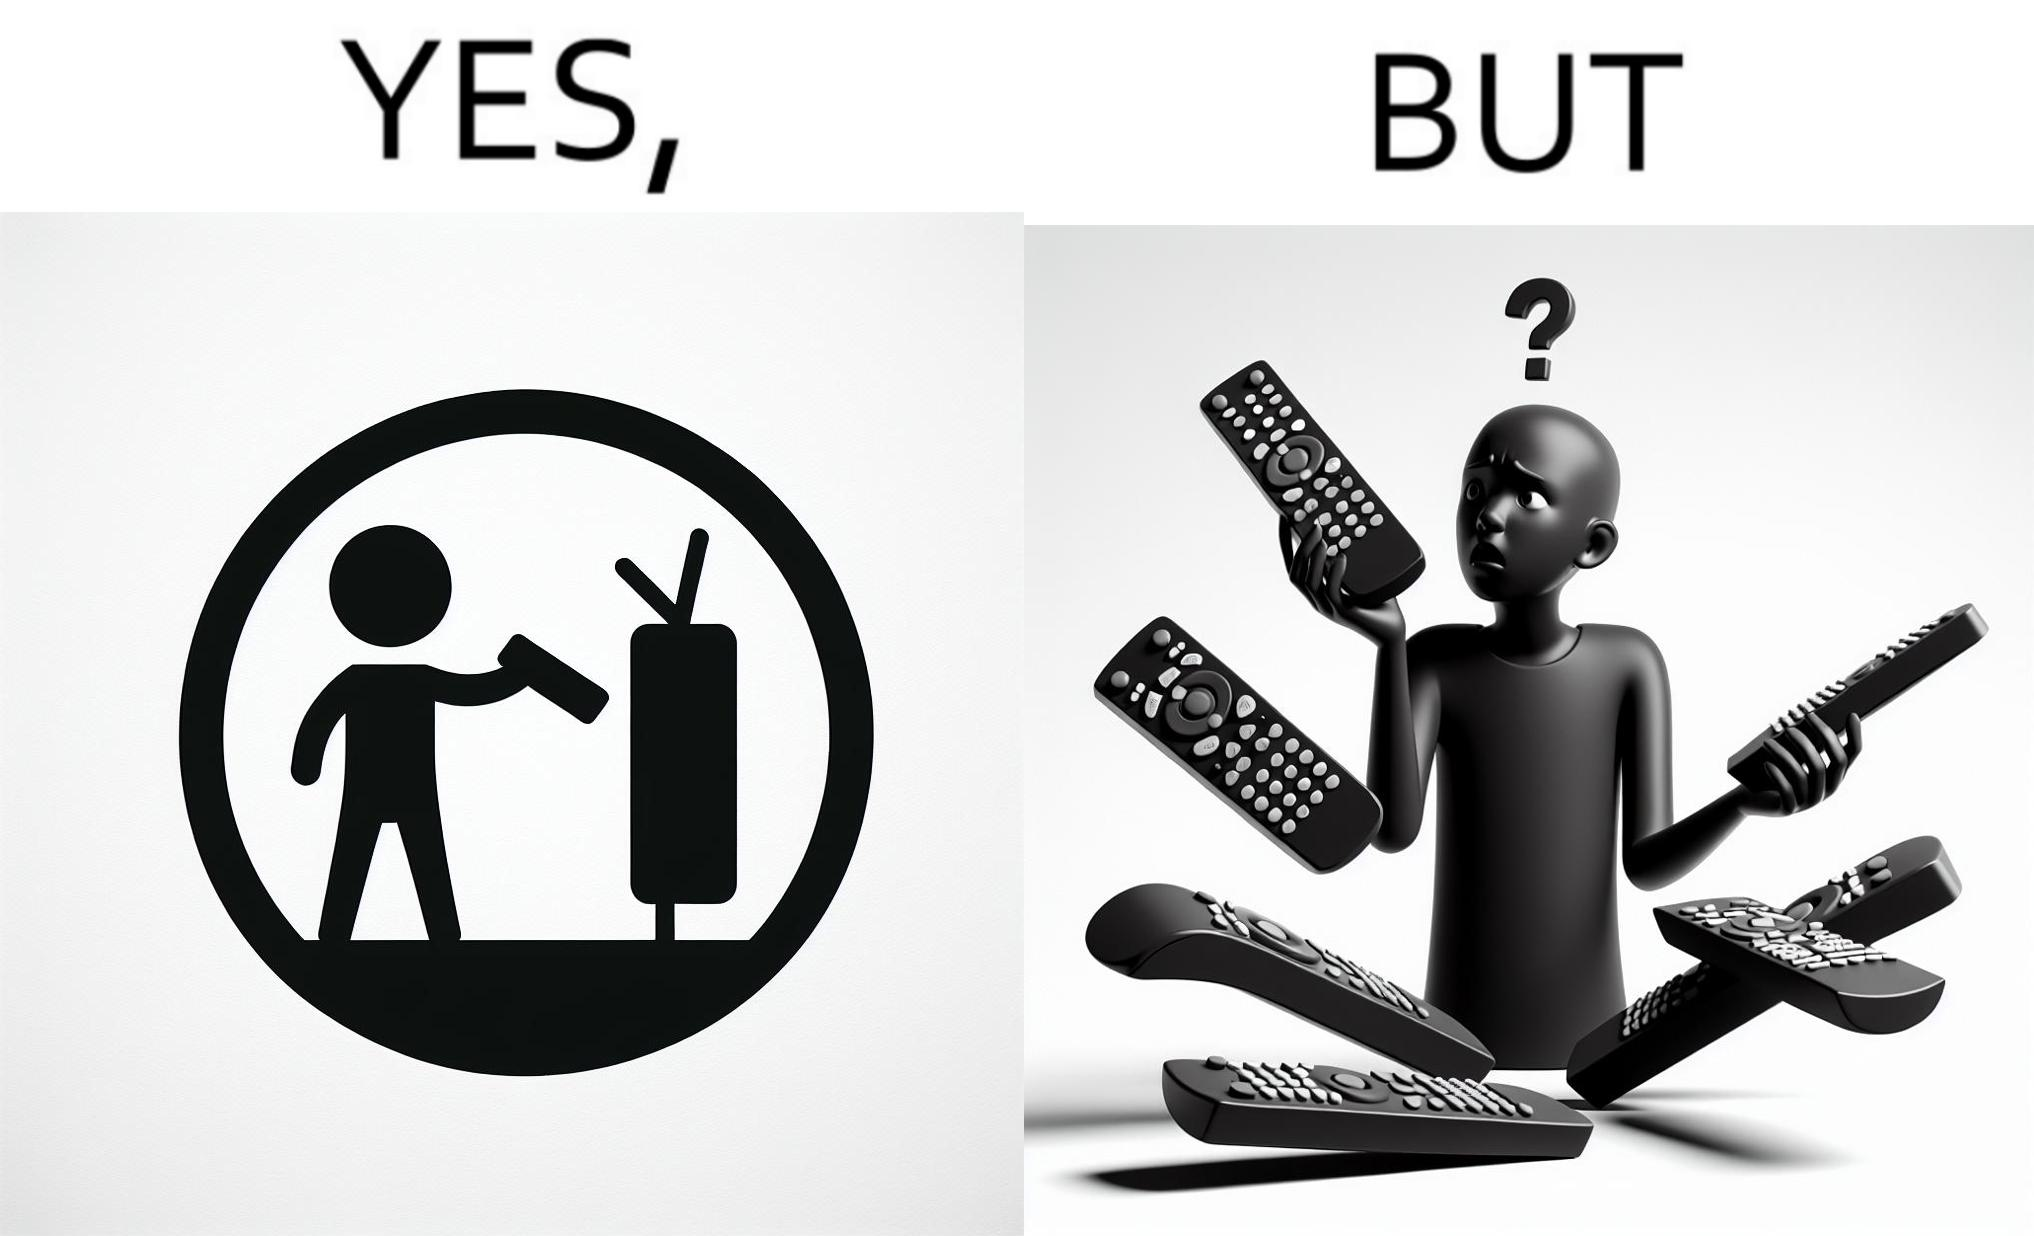What is the satirical meaning behind this image? The images are funny since they show how even though TV remotes are supposed to make operating TVs easier, having multiple similar looking remotes  for everything only makes it more difficult for the user to use the right one 